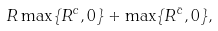Convert formula to latex. <formula><loc_0><loc_0><loc_500><loc_500>R \max \{ R ^ { c } , 0 \} + \max \{ R ^ { \bar { c } } , 0 \} ,</formula> 